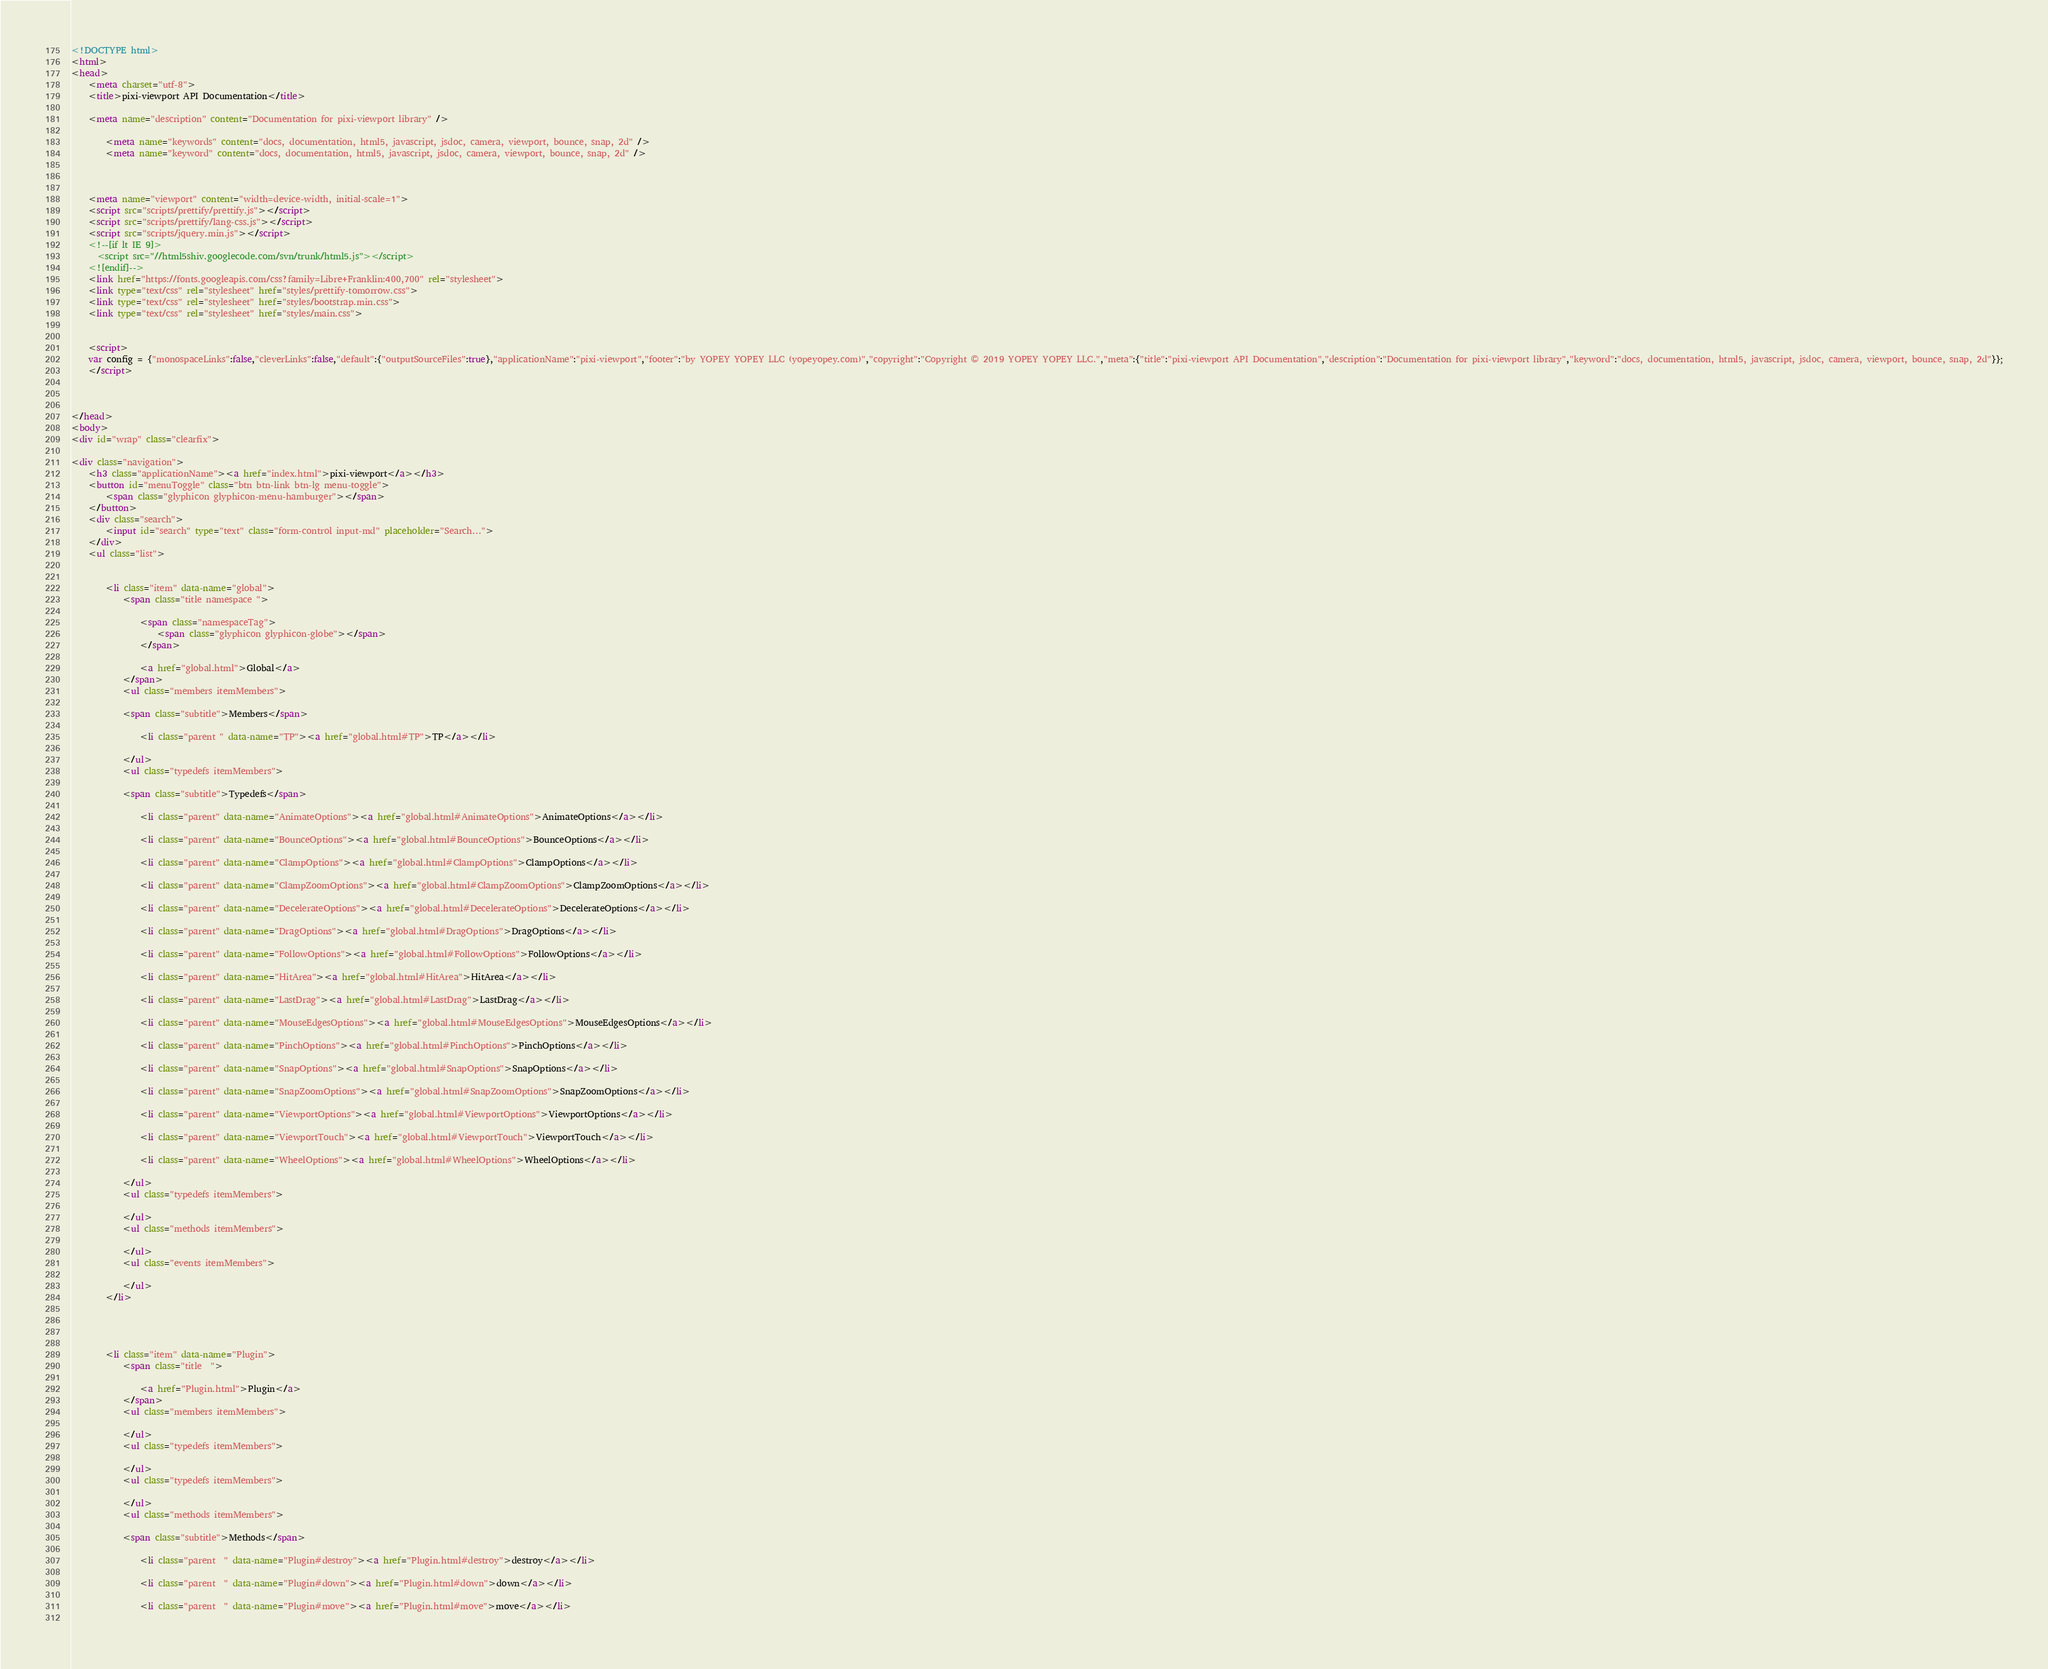Convert code to text. <code><loc_0><loc_0><loc_500><loc_500><_HTML_><!DOCTYPE html>
<html>
<head>
    <meta charset="utf-8">
    <title>pixi-viewport API Documentation</title>
    
    <meta name="description" content="Documentation for pixi-viewport library" />
    
        <meta name="keywords" content="docs, documentation, html5, javascript, jsdoc, camera, viewport, bounce, snap, 2d" />
        <meta name="keyword" content="docs, documentation, html5, javascript, jsdoc, camera, viewport, bounce, snap, 2d" />
    
    
    
    <meta name="viewport" content="width=device-width, initial-scale=1">
    <script src="scripts/prettify/prettify.js"></script>
    <script src="scripts/prettify/lang-css.js"></script>
    <script src="scripts/jquery.min.js"></script>
    <!--[if lt IE 9]>
      <script src="//html5shiv.googlecode.com/svn/trunk/html5.js"></script>
    <![endif]-->
    <link href="https://fonts.googleapis.com/css?family=Libre+Franklin:400,700" rel="stylesheet">
    <link type="text/css" rel="stylesheet" href="styles/prettify-tomorrow.css">
    <link type="text/css" rel="stylesheet" href="styles/bootstrap.min.css">
    <link type="text/css" rel="stylesheet" href="styles/main.css">

    
    <script>
    var config = {"monospaceLinks":false,"cleverLinks":false,"default":{"outputSourceFiles":true},"applicationName":"pixi-viewport","footer":"by YOPEY YOPEY LLC (yopeyopey.com)","copyright":"Copyright © 2019 YOPEY YOPEY LLC.","meta":{"title":"pixi-viewport API Documentation","description":"Documentation for pixi-viewport library","keyword":"docs, documentation, html5, javascript, jsdoc, camera, viewport, bounce, snap, 2d"}};
    </script>
    

    
</head>
<body>
<div id="wrap" class="clearfix">
    
<div class="navigation">
    <h3 class="applicationName"><a href="index.html">pixi-viewport</a></h3>
    <button id="menuToggle" class="btn btn-link btn-lg menu-toggle">
        <span class="glyphicon glyphicon-menu-hamburger"></span>
    </button>
    <div class="search">
        <input id="search" type="text" class="form-control input-md" placeholder="Search...">
    </div>
    <ul class="list">
    
        
        <li class="item" data-name="global">
            <span class="title namespace ">
                
                <span class="namespaceTag">
                    <span class="glyphicon glyphicon-globe"></span>
                </span>
                
                <a href="global.html">Global</a>
            </span>
            <ul class="members itemMembers">
            
            <span class="subtitle">Members</span>
            
                <li class="parent " data-name="TP"><a href="global.html#TP">TP</a></li>
            
            </ul>
            <ul class="typedefs itemMembers">
            
            <span class="subtitle">Typedefs</span>
            
                <li class="parent" data-name="AnimateOptions"><a href="global.html#AnimateOptions">AnimateOptions</a></li>
            
                <li class="parent" data-name="BounceOptions"><a href="global.html#BounceOptions">BounceOptions</a></li>
            
                <li class="parent" data-name="ClampOptions"><a href="global.html#ClampOptions">ClampOptions</a></li>
            
                <li class="parent" data-name="ClampZoomOptions"><a href="global.html#ClampZoomOptions">ClampZoomOptions</a></li>
            
                <li class="parent" data-name="DecelerateOptions"><a href="global.html#DecelerateOptions">DecelerateOptions</a></li>
            
                <li class="parent" data-name="DragOptions"><a href="global.html#DragOptions">DragOptions</a></li>
            
                <li class="parent" data-name="FollowOptions"><a href="global.html#FollowOptions">FollowOptions</a></li>
            
                <li class="parent" data-name="HitArea"><a href="global.html#HitArea">HitArea</a></li>
            
                <li class="parent" data-name="LastDrag"><a href="global.html#LastDrag">LastDrag</a></li>
            
                <li class="parent" data-name="MouseEdgesOptions"><a href="global.html#MouseEdgesOptions">MouseEdgesOptions</a></li>
            
                <li class="parent" data-name="PinchOptions"><a href="global.html#PinchOptions">PinchOptions</a></li>
            
                <li class="parent" data-name="SnapOptions"><a href="global.html#SnapOptions">SnapOptions</a></li>
            
                <li class="parent" data-name="SnapZoomOptions"><a href="global.html#SnapZoomOptions">SnapZoomOptions</a></li>
            
                <li class="parent" data-name="ViewportOptions"><a href="global.html#ViewportOptions">ViewportOptions</a></li>
            
                <li class="parent" data-name="ViewportTouch"><a href="global.html#ViewportTouch">ViewportTouch</a></li>
            
                <li class="parent" data-name="WheelOptions"><a href="global.html#WheelOptions">WheelOptions</a></li>
            
            </ul>
            <ul class="typedefs itemMembers">
            
            </ul>
            <ul class="methods itemMembers">
            
            </ul>
            <ul class="events itemMembers">
            
            </ul>
        </li>
    
        
    
        
        <li class="item" data-name="Plugin">
            <span class="title  ">
                
                <a href="Plugin.html">Plugin</a>
            </span>
            <ul class="members itemMembers">
            
            </ul>
            <ul class="typedefs itemMembers">
            
            </ul>
            <ul class="typedefs itemMembers">
            
            </ul>
            <ul class="methods itemMembers">
            
            <span class="subtitle">Methods</span>
            
                <li class="parent  " data-name="Plugin#destroy"><a href="Plugin.html#destroy">destroy</a></li>
            
                <li class="parent  " data-name="Plugin#down"><a href="Plugin.html#down">down</a></li>
            
                <li class="parent  " data-name="Plugin#move"><a href="Plugin.html#move">move</a></li>
            </code> 